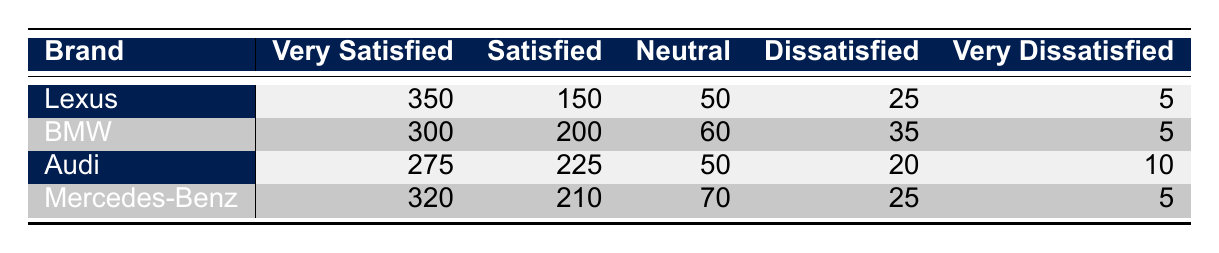What is the total number of customers who are "Very Satisfied" with Lexus? According to the table, Lexus has 350 customers who reported being "Very Satisfied."
Answer: 350 How many customers are dissatisfied with BMW? BMW has 35 customers who reported being "Dissatisfied."
Answer: 35 Which brand has the highest number of "Satisfied" customers? BMW has 200 "Satisfied" customers, which is the highest compared to Lexus (150), Audi (225), and Mercedes-Benz (210).
Answer: Audi What is the average number of "Neutral" ratings across all brands? The "Neutral" ratings are 50 (Lexus) + 60 (BMW) + 50 (Audi) + 70 (Mercedes-Benz) = 230. Dividing by 4 brands gives an average of 230/4 = 57.5.
Answer: 57.5 Is it true that more customers are "Very Dissatisfied" with Audi than with BMW? Audi has 10 customers who are "Very Dissatisfied," while BMW has 5. Therefore, it is false that more customers are "Very Dissatisfied" with Audi than with BMW.
Answer: No What is the difference in "Very Satisfied" ratings between Lexus and Mercedes-Benz? Lexus has 350 "Very Satisfied" ratings and Mercedes-Benz has 320. The difference is 350 - 320 = 30.
Answer: 30 How many total customers rated Audi as either "Dissatisfied" or "Very Dissatisfied"? Audi has 20 customers "Dissatisfied" and 10 "Very Dissatisfied." Adding these together gives 20 + 10 = 30.
Answer: 30 Which satisfaction rating has the fewest customers for Lexus? Lexus has 5 customers in the "Very Dissatisfied" category, which is the fewest compared to other satisfaction ratings.
Answer: Very Dissatisfied What percentage of BMW customers are "Satisfied"? BMW has 200 "Satisfied" customers out of a total of (300 + 200 + 60 + 35 + 5) = 600 customers. The percentage is (200/600) * 100 = 33.33%.
Answer: 33.33% 